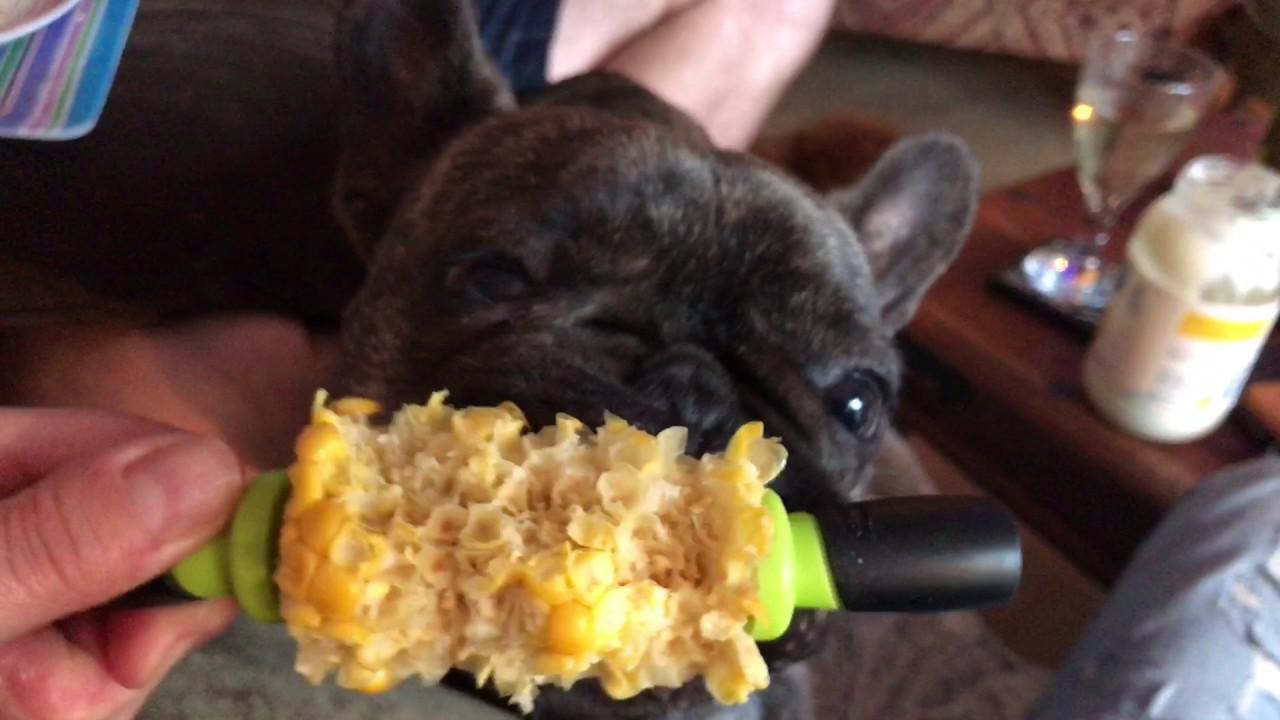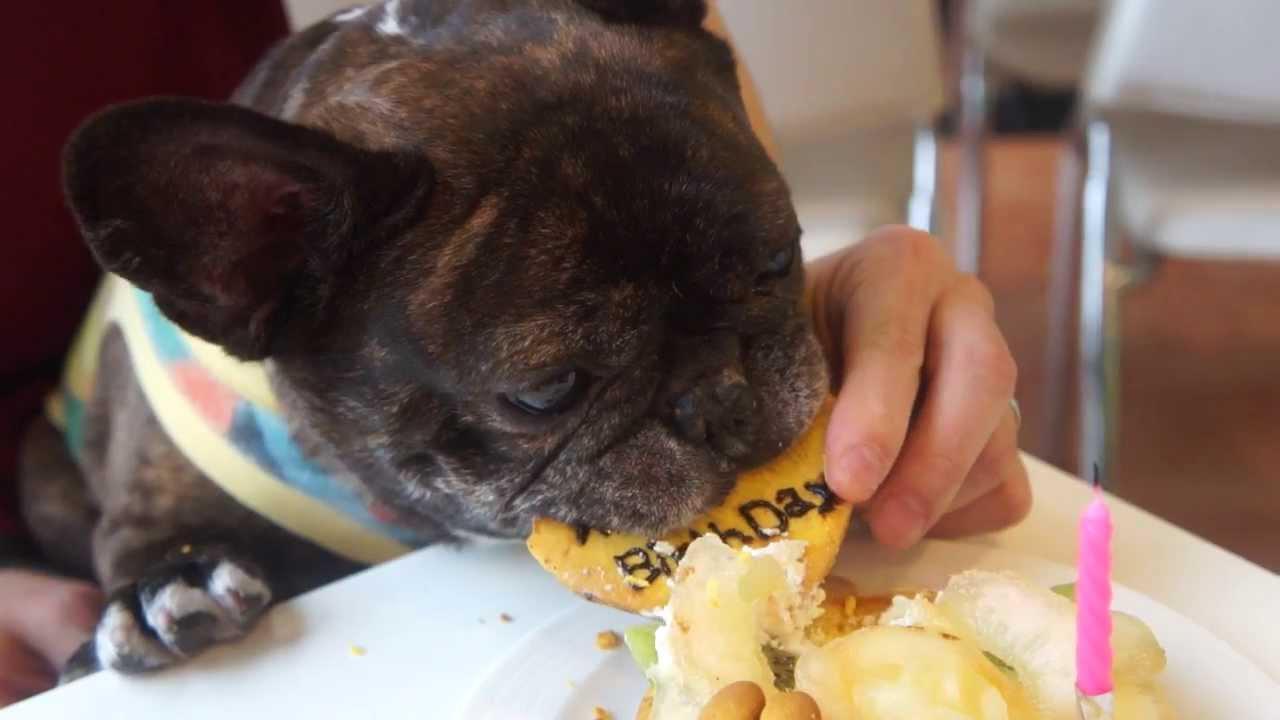The first image is the image on the left, the second image is the image on the right. Assess this claim about the two images: "A person is feeding a dog by hand.". Correct or not? Answer yes or no. Yes. The first image is the image on the left, the second image is the image on the right. Considering the images on both sides, is "Each image contains a french bulldog with brindle fur that is eating, or trying to eat, human food." valid? Answer yes or no. Yes. 